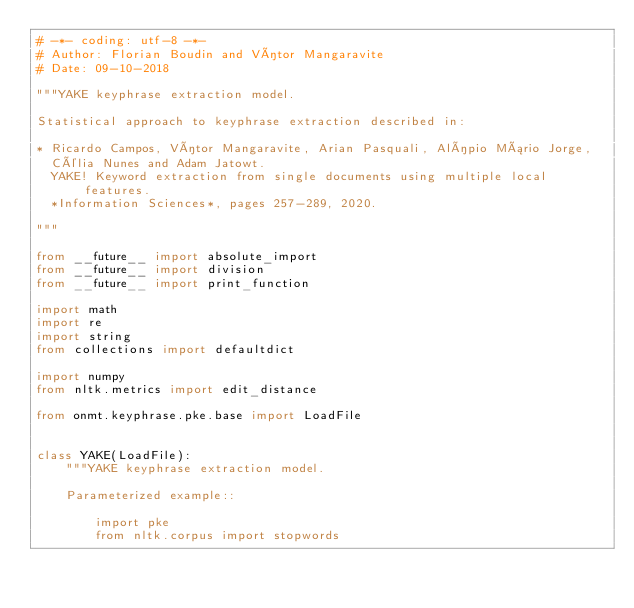<code> <loc_0><loc_0><loc_500><loc_500><_Python_># -*- coding: utf-8 -*-
# Author: Florian Boudin and Vítor Mangaravite
# Date: 09-10-2018

"""YAKE keyphrase extraction model.

Statistical approach to keyphrase extraction described in:

* Ricardo Campos, Vítor Mangaravite, Arian Pasquali, Alípio Mário Jorge,
  Célia Nunes and Adam Jatowt.
  YAKE! Keyword extraction from single documents using multiple local features.
  *Information Sciences*, pages 257-289, 2020.

"""

from __future__ import absolute_import
from __future__ import division
from __future__ import print_function

import math
import re
import string
from collections import defaultdict

import numpy
from nltk.metrics import edit_distance

from onmt.keyphrase.pke.base import LoadFile


class YAKE(LoadFile):
    """YAKE keyphrase extraction model.

    Parameterized example::

        import pke
        from nltk.corpus import stopwords
</code> 